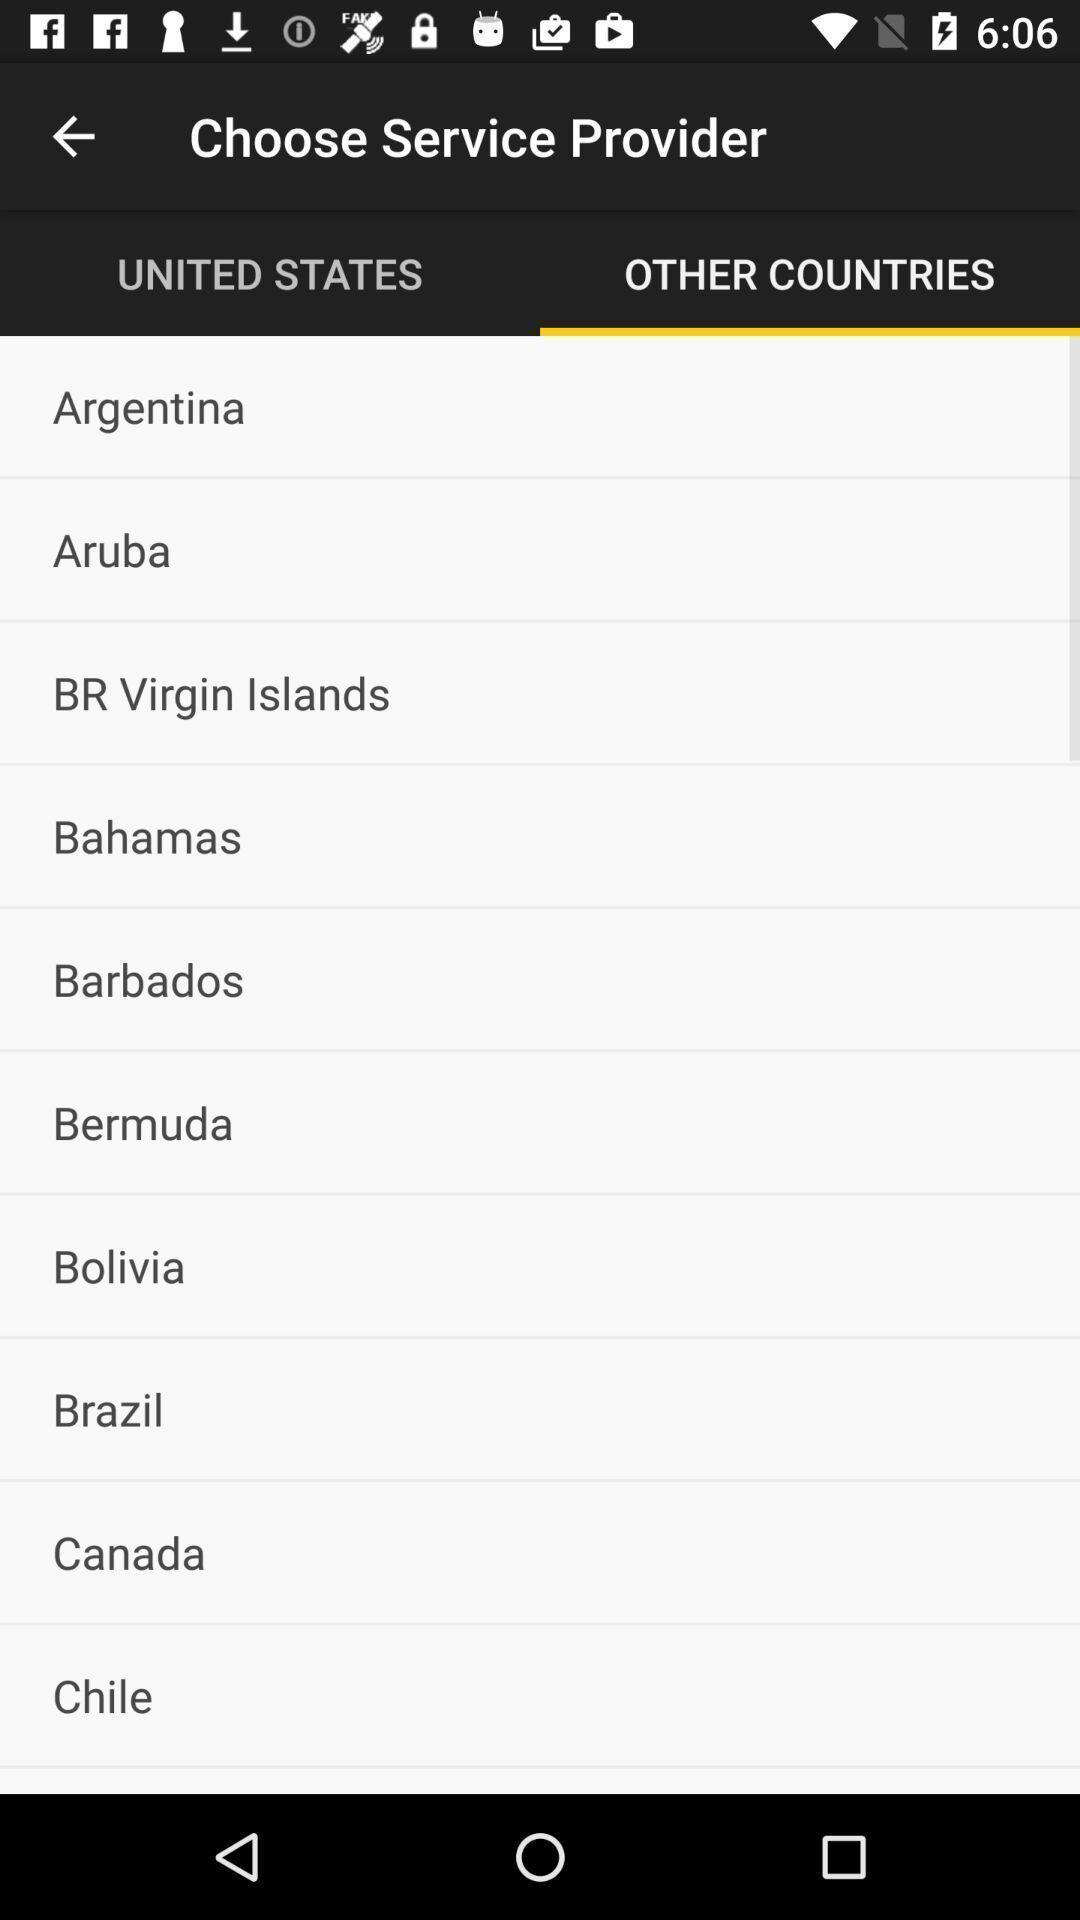Describe the content in this image. Screen displaying list of countries. 